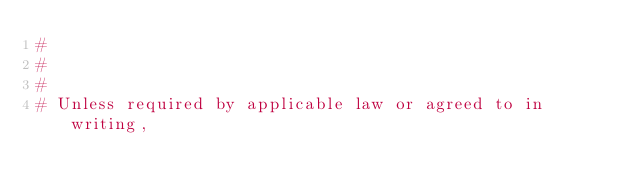<code> <loc_0><loc_0><loc_500><loc_500><_Python_>#
#
#
# Unless required by applicable law or agreed to in writing,</code> 